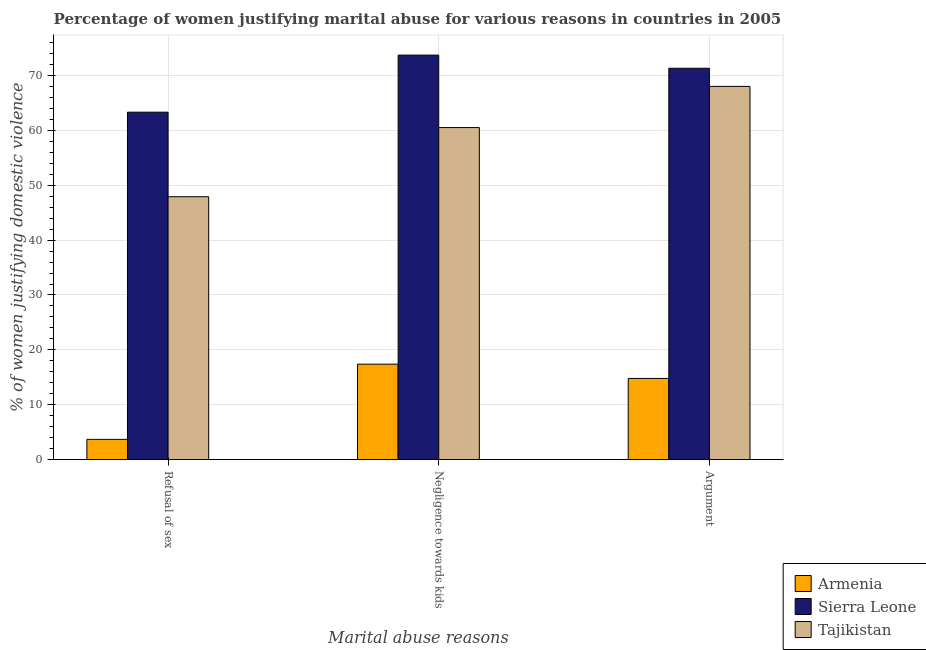How many different coloured bars are there?
Keep it short and to the point. 3. What is the label of the 2nd group of bars from the left?
Your answer should be compact. Negligence towards kids. What is the percentage of women justifying domestic violence due to arguments in Armenia?
Your answer should be very brief. 14.8. Across all countries, what is the maximum percentage of women justifying domestic violence due to arguments?
Keep it short and to the point. 71.3. In which country was the percentage of women justifying domestic violence due to arguments maximum?
Your answer should be very brief. Sierra Leone. In which country was the percentage of women justifying domestic violence due to arguments minimum?
Make the answer very short. Armenia. What is the total percentage of women justifying domestic violence due to refusal of sex in the graph?
Offer a very short reply. 114.9. What is the difference between the percentage of women justifying domestic violence due to arguments in Tajikistan and that in Armenia?
Offer a terse response. 53.2. What is the difference between the percentage of women justifying domestic violence due to arguments in Sierra Leone and the percentage of women justifying domestic violence due to negligence towards kids in Tajikistan?
Provide a short and direct response. 10.8. What is the average percentage of women justifying domestic violence due to arguments per country?
Offer a very short reply. 51.37. What is the ratio of the percentage of women justifying domestic violence due to arguments in Armenia to that in Tajikistan?
Ensure brevity in your answer.  0.22. Is the percentage of women justifying domestic violence due to arguments in Sierra Leone less than that in Tajikistan?
Ensure brevity in your answer.  No. What is the difference between the highest and the second highest percentage of women justifying domestic violence due to negligence towards kids?
Keep it short and to the point. 13.2. What is the difference between the highest and the lowest percentage of women justifying domestic violence due to negligence towards kids?
Keep it short and to the point. 56.3. In how many countries, is the percentage of women justifying domestic violence due to negligence towards kids greater than the average percentage of women justifying domestic violence due to negligence towards kids taken over all countries?
Provide a short and direct response. 2. What does the 1st bar from the left in Argument represents?
Make the answer very short. Armenia. What does the 1st bar from the right in Negligence towards kids represents?
Your response must be concise. Tajikistan. Is it the case that in every country, the sum of the percentage of women justifying domestic violence due to refusal of sex and percentage of women justifying domestic violence due to negligence towards kids is greater than the percentage of women justifying domestic violence due to arguments?
Give a very brief answer. Yes. How many bars are there?
Provide a short and direct response. 9. Are all the bars in the graph horizontal?
Provide a succinct answer. No. What is the difference between two consecutive major ticks on the Y-axis?
Offer a very short reply. 10. Does the graph contain any zero values?
Provide a short and direct response. No. How are the legend labels stacked?
Provide a succinct answer. Vertical. What is the title of the graph?
Offer a very short reply. Percentage of women justifying marital abuse for various reasons in countries in 2005. Does "Sub-Saharan Africa (developing only)" appear as one of the legend labels in the graph?
Offer a terse response. No. What is the label or title of the X-axis?
Ensure brevity in your answer.  Marital abuse reasons. What is the label or title of the Y-axis?
Make the answer very short. % of women justifying domestic violence. What is the % of women justifying domestic violence of Sierra Leone in Refusal of sex?
Keep it short and to the point. 63.3. What is the % of women justifying domestic violence in Tajikistan in Refusal of sex?
Provide a short and direct response. 47.9. What is the % of women justifying domestic violence of Armenia in Negligence towards kids?
Ensure brevity in your answer.  17.4. What is the % of women justifying domestic violence in Sierra Leone in Negligence towards kids?
Offer a very short reply. 73.7. What is the % of women justifying domestic violence of Tajikistan in Negligence towards kids?
Offer a terse response. 60.5. What is the % of women justifying domestic violence in Sierra Leone in Argument?
Your response must be concise. 71.3. Across all Marital abuse reasons, what is the maximum % of women justifying domestic violence in Sierra Leone?
Offer a very short reply. 73.7. Across all Marital abuse reasons, what is the maximum % of women justifying domestic violence in Tajikistan?
Provide a short and direct response. 68. Across all Marital abuse reasons, what is the minimum % of women justifying domestic violence of Armenia?
Provide a succinct answer. 3.7. Across all Marital abuse reasons, what is the minimum % of women justifying domestic violence in Sierra Leone?
Your response must be concise. 63.3. Across all Marital abuse reasons, what is the minimum % of women justifying domestic violence of Tajikistan?
Ensure brevity in your answer.  47.9. What is the total % of women justifying domestic violence in Armenia in the graph?
Make the answer very short. 35.9. What is the total % of women justifying domestic violence in Sierra Leone in the graph?
Your answer should be compact. 208.3. What is the total % of women justifying domestic violence of Tajikistan in the graph?
Provide a short and direct response. 176.4. What is the difference between the % of women justifying domestic violence in Armenia in Refusal of sex and that in Negligence towards kids?
Offer a terse response. -13.7. What is the difference between the % of women justifying domestic violence in Armenia in Refusal of sex and that in Argument?
Your response must be concise. -11.1. What is the difference between the % of women justifying domestic violence of Sierra Leone in Refusal of sex and that in Argument?
Make the answer very short. -8. What is the difference between the % of women justifying domestic violence in Tajikistan in Refusal of sex and that in Argument?
Provide a succinct answer. -20.1. What is the difference between the % of women justifying domestic violence in Sierra Leone in Negligence towards kids and that in Argument?
Ensure brevity in your answer.  2.4. What is the difference between the % of women justifying domestic violence of Tajikistan in Negligence towards kids and that in Argument?
Make the answer very short. -7.5. What is the difference between the % of women justifying domestic violence in Armenia in Refusal of sex and the % of women justifying domestic violence in Sierra Leone in Negligence towards kids?
Offer a very short reply. -70. What is the difference between the % of women justifying domestic violence of Armenia in Refusal of sex and the % of women justifying domestic violence of Tajikistan in Negligence towards kids?
Your response must be concise. -56.8. What is the difference between the % of women justifying domestic violence in Sierra Leone in Refusal of sex and the % of women justifying domestic violence in Tajikistan in Negligence towards kids?
Give a very brief answer. 2.8. What is the difference between the % of women justifying domestic violence of Armenia in Refusal of sex and the % of women justifying domestic violence of Sierra Leone in Argument?
Provide a succinct answer. -67.6. What is the difference between the % of women justifying domestic violence of Armenia in Refusal of sex and the % of women justifying domestic violence of Tajikistan in Argument?
Give a very brief answer. -64.3. What is the difference between the % of women justifying domestic violence in Sierra Leone in Refusal of sex and the % of women justifying domestic violence in Tajikistan in Argument?
Ensure brevity in your answer.  -4.7. What is the difference between the % of women justifying domestic violence of Armenia in Negligence towards kids and the % of women justifying domestic violence of Sierra Leone in Argument?
Keep it short and to the point. -53.9. What is the difference between the % of women justifying domestic violence in Armenia in Negligence towards kids and the % of women justifying domestic violence in Tajikistan in Argument?
Provide a succinct answer. -50.6. What is the difference between the % of women justifying domestic violence of Sierra Leone in Negligence towards kids and the % of women justifying domestic violence of Tajikistan in Argument?
Provide a short and direct response. 5.7. What is the average % of women justifying domestic violence in Armenia per Marital abuse reasons?
Offer a very short reply. 11.97. What is the average % of women justifying domestic violence of Sierra Leone per Marital abuse reasons?
Keep it short and to the point. 69.43. What is the average % of women justifying domestic violence in Tajikistan per Marital abuse reasons?
Make the answer very short. 58.8. What is the difference between the % of women justifying domestic violence of Armenia and % of women justifying domestic violence of Sierra Leone in Refusal of sex?
Give a very brief answer. -59.6. What is the difference between the % of women justifying domestic violence in Armenia and % of women justifying domestic violence in Tajikistan in Refusal of sex?
Your response must be concise. -44.2. What is the difference between the % of women justifying domestic violence of Armenia and % of women justifying domestic violence of Sierra Leone in Negligence towards kids?
Offer a very short reply. -56.3. What is the difference between the % of women justifying domestic violence in Armenia and % of women justifying domestic violence in Tajikistan in Negligence towards kids?
Make the answer very short. -43.1. What is the difference between the % of women justifying domestic violence of Sierra Leone and % of women justifying domestic violence of Tajikistan in Negligence towards kids?
Your answer should be very brief. 13.2. What is the difference between the % of women justifying domestic violence of Armenia and % of women justifying domestic violence of Sierra Leone in Argument?
Offer a very short reply. -56.5. What is the difference between the % of women justifying domestic violence of Armenia and % of women justifying domestic violence of Tajikistan in Argument?
Offer a very short reply. -53.2. What is the difference between the % of women justifying domestic violence in Sierra Leone and % of women justifying domestic violence in Tajikistan in Argument?
Your response must be concise. 3.3. What is the ratio of the % of women justifying domestic violence of Armenia in Refusal of sex to that in Negligence towards kids?
Your response must be concise. 0.21. What is the ratio of the % of women justifying domestic violence of Sierra Leone in Refusal of sex to that in Negligence towards kids?
Your answer should be compact. 0.86. What is the ratio of the % of women justifying domestic violence of Tajikistan in Refusal of sex to that in Negligence towards kids?
Offer a terse response. 0.79. What is the ratio of the % of women justifying domestic violence in Armenia in Refusal of sex to that in Argument?
Offer a terse response. 0.25. What is the ratio of the % of women justifying domestic violence of Sierra Leone in Refusal of sex to that in Argument?
Provide a short and direct response. 0.89. What is the ratio of the % of women justifying domestic violence of Tajikistan in Refusal of sex to that in Argument?
Your answer should be compact. 0.7. What is the ratio of the % of women justifying domestic violence in Armenia in Negligence towards kids to that in Argument?
Offer a terse response. 1.18. What is the ratio of the % of women justifying domestic violence of Sierra Leone in Negligence towards kids to that in Argument?
Provide a succinct answer. 1.03. What is the ratio of the % of women justifying domestic violence in Tajikistan in Negligence towards kids to that in Argument?
Offer a terse response. 0.89. What is the difference between the highest and the second highest % of women justifying domestic violence in Armenia?
Provide a succinct answer. 2.6. What is the difference between the highest and the second highest % of women justifying domestic violence in Tajikistan?
Your response must be concise. 7.5. What is the difference between the highest and the lowest % of women justifying domestic violence of Sierra Leone?
Provide a short and direct response. 10.4. What is the difference between the highest and the lowest % of women justifying domestic violence in Tajikistan?
Offer a very short reply. 20.1. 